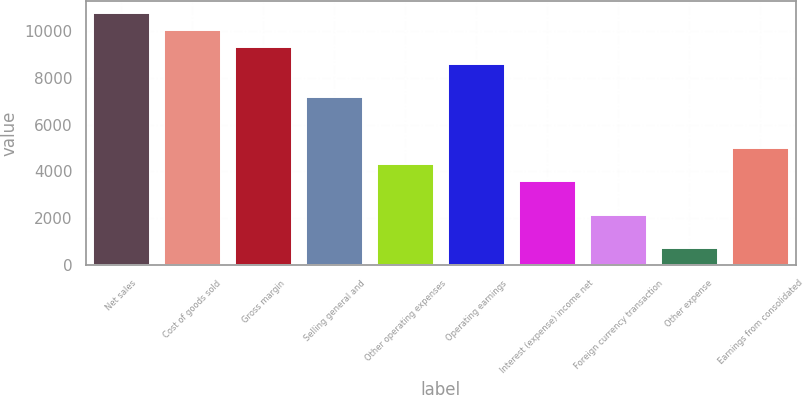Convert chart. <chart><loc_0><loc_0><loc_500><loc_500><bar_chart><fcel>Net sales<fcel>Cost of goods sold<fcel>Gross margin<fcel>Selling general and<fcel>Other operating expenses<fcel>Operating earnings<fcel>Interest (expense) income net<fcel>Foreign currency transaction<fcel>Other expense<fcel>Earnings from consolidated<nl><fcel>10742.5<fcel>10026.6<fcel>9310.62<fcel>7162.8<fcel>4299.04<fcel>8594.68<fcel>3583.1<fcel>2151.22<fcel>719.34<fcel>5014.98<nl></chart> 